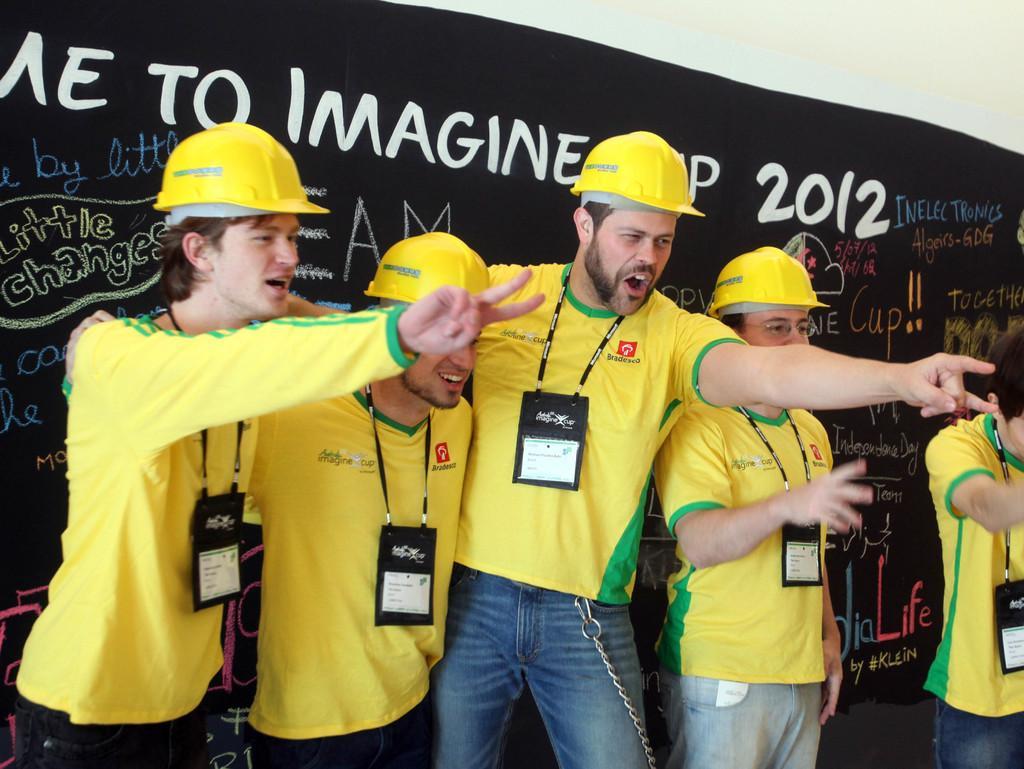Could you give a brief overview of what you see in this image? In the picture we can see some people are standing and doing some action and they are in yellow T-shirts and caps and behind them, we can see a wall with a black color board and something written on it. 